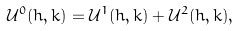Convert formula to latex. <formula><loc_0><loc_0><loc_500><loc_500>\mathcal { U } ^ { 0 } ( h , k ) = \mathcal { U } ^ { 1 } ( h , k ) + \mathcal { U } ^ { 2 } ( h , k ) ,</formula> 